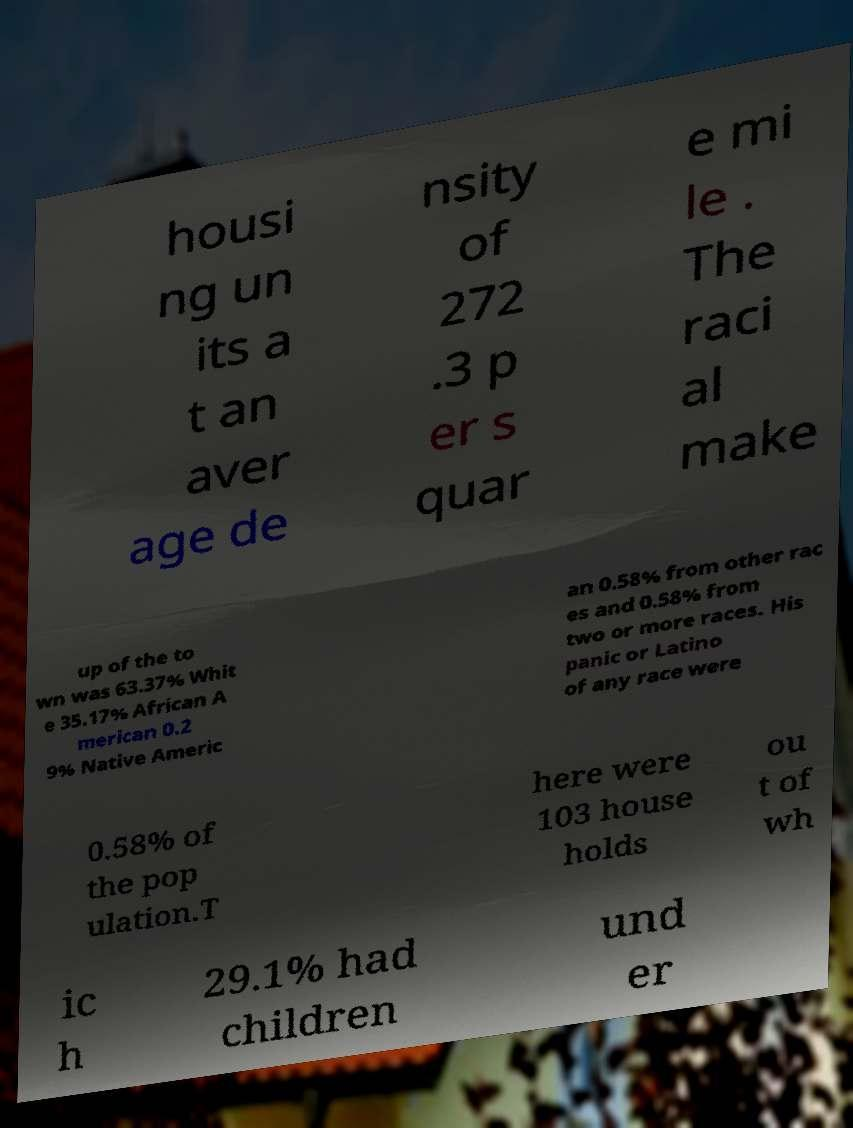Could you extract and type out the text from this image? housi ng un its a t an aver age de nsity of 272 .3 p er s quar e mi le . The raci al make up of the to wn was 63.37% Whit e 35.17% African A merican 0.2 9% Native Americ an 0.58% from other rac es and 0.58% from two or more races. His panic or Latino of any race were 0.58% of the pop ulation.T here were 103 house holds ou t of wh ic h 29.1% had children und er 